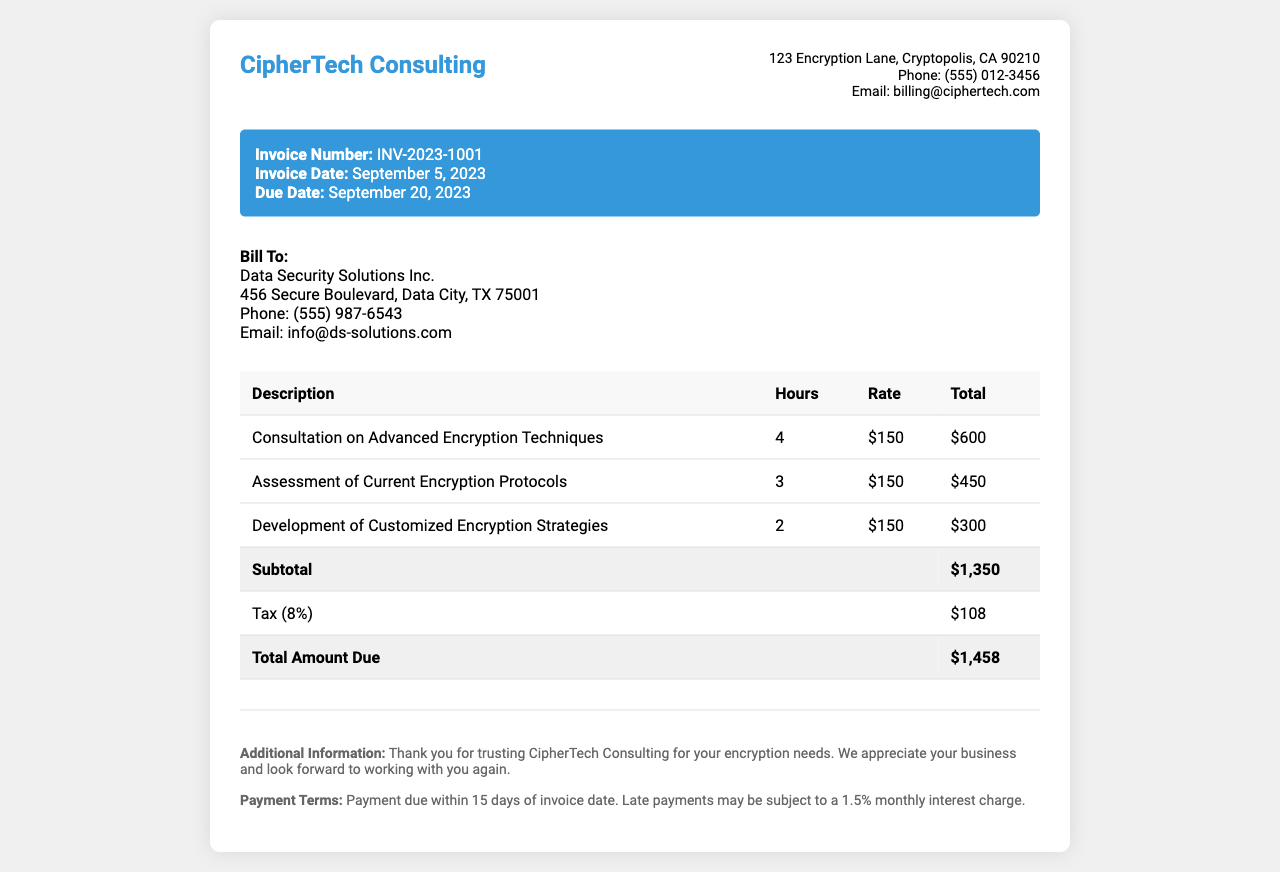What is the invoice number? The invoice number is specifically mentioned in the invoice details section.
Answer: INV-2023-1001 Who is the client? The client is identified in the bill-to section of the document.
Answer: Data Security Solutions Inc What is the total amount due? The total amount due is stated at the bottom of the table summarizing the charges.
Answer: $1,458 How many hours were spent on the development of customized encryption strategies? The number of hours for this task is listed in the services provided section of the invoice.
Answer: 2 What was the subtotal before tax? The subtotal before tax is shown in the summary of charges within the table.
Answer: $1,350 What is the due date for payment? The due date is indicated in the invoice details section as requiring payment by a certain date.
Answer: September 20, 2023 What was the rate for the consultation on advanced encryption techniques? The rate for each hour of consultation is specified in the table of services provided.
Answer: $150 What is the tax percentage applied to the subtotal? The tax percentage is indicated in the summary of services, showing the applicable tax rate.
Answer: 8% What is the payment term mentioned in the invoice? The payment term details are found towards the end of the document in the notes section.
Answer: Payment due within 15 days of invoice date 